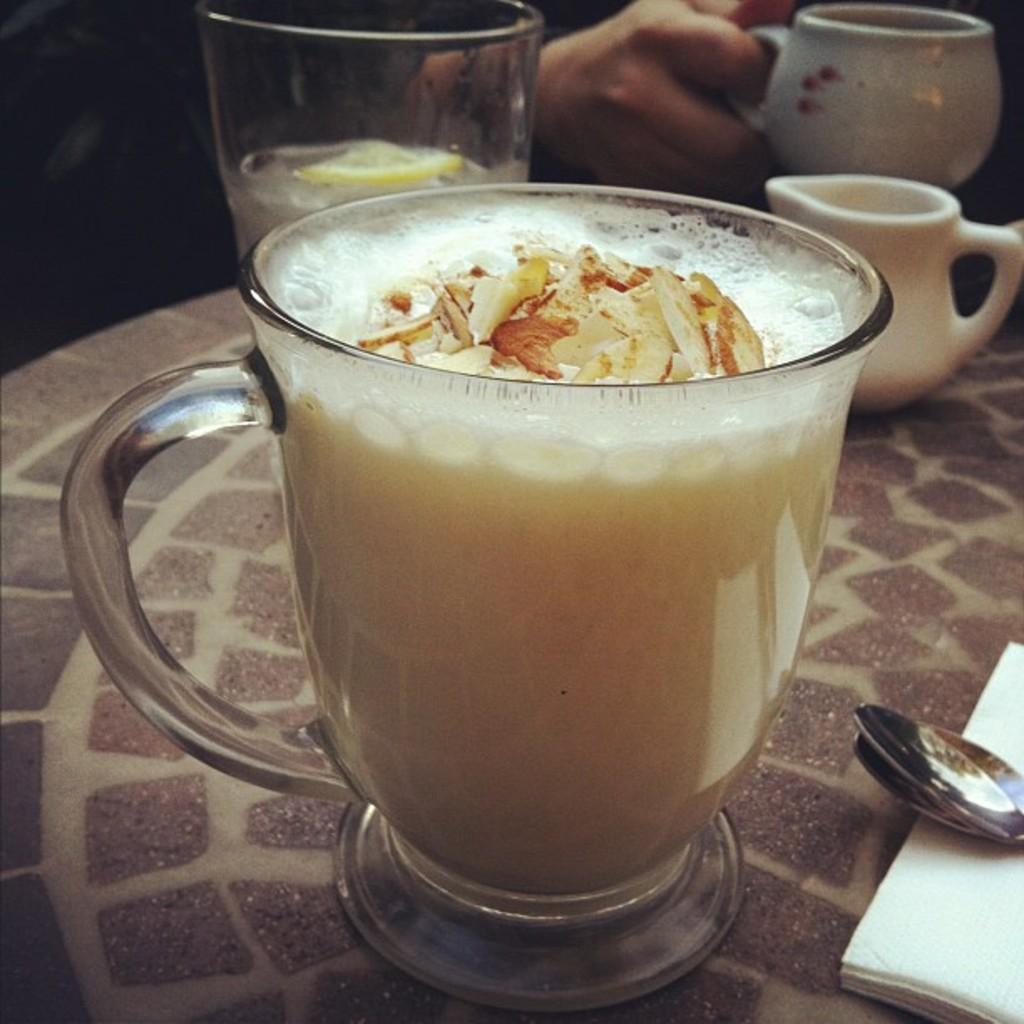What is in the cup that is visible in the image? There is a drink in the cup that is visible in the image. What utensil can be seen on the table in the image? There is a spoon on the table in the image. Can you describe the person in the background of the image? A person is holding a cup in the background of the image. How many kittens are playing with the cup in the image? There are no kittens present in the image. What type of cup is being used by the person in the front of the image? There is no person in the front of the image; the person is in the background holding a cup. 